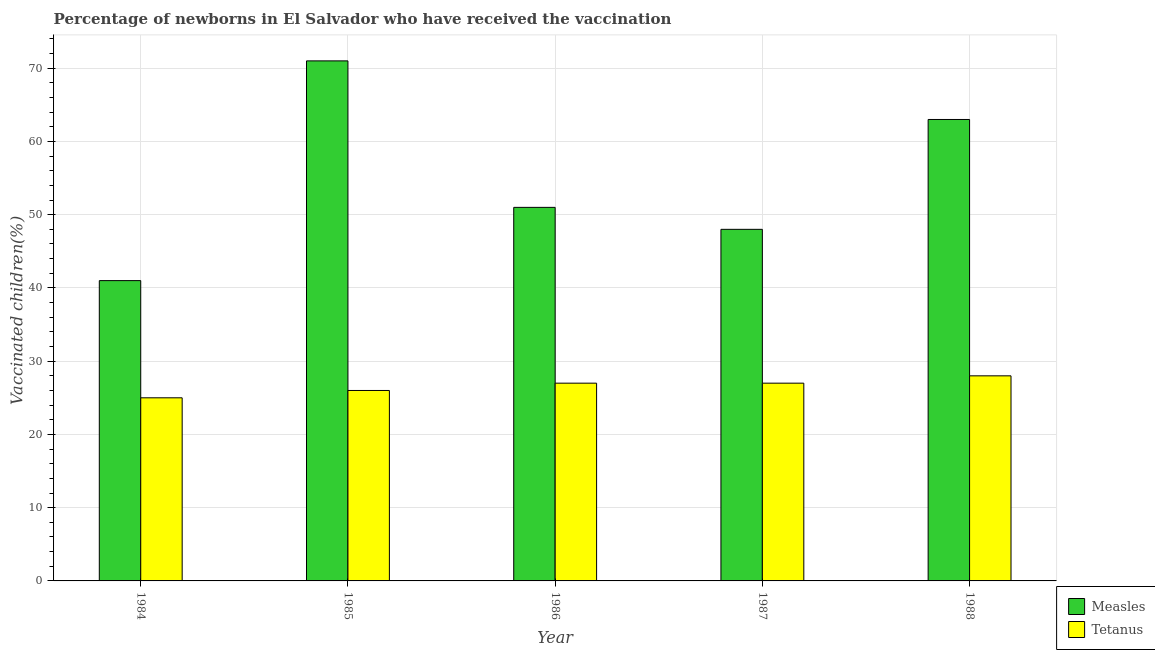How many different coloured bars are there?
Offer a terse response. 2. Are the number of bars per tick equal to the number of legend labels?
Your answer should be compact. Yes. Are the number of bars on each tick of the X-axis equal?
Provide a succinct answer. Yes. How many bars are there on the 3rd tick from the left?
Give a very brief answer. 2. What is the label of the 2nd group of bars from the left?
Ensure brevity in your answer.  1985. What is the percentage of newborns who received vaccination for measles in 1988?
Ensure brevity in your answer.  63. Across all years, what is the maximum percentage of newborns who received vaccination for tetanus?
Offer a very short reply. 28. Across all years, what is the minimum percentage of newborns who received vaccination for measles?
Provide a short and direct response. 41. In which year was the percentage of newborns who received vaccination for measles minimum?
Give a very brief answer. 1984. What is the total percentage of newborns who received vaccination for tetanus in the graph?
Your answer should be compact. 133. What is the difference between the percentage of newborns who received vaccination for measles in 1984 and that in 1988?
Offer a terse response. -22. What is the difference between the percentage of newborns who received vaccination for measles in 1985 and the percentage of newborns who received vaccination for tetanus in 1987?
Make the answer very short. 23. What is the average percentage of newborns who received vaccination for tetanus per year?
Your answer should be very brief. 26.6. In the year 1984, what is the difference between the percentage of newborns who received vaccination for measles and percentage of newborns who received vaccination for tetanus?
Offer a very short reply. 0. What is the ratio of the percentage of newborns who received vaccination for tetanus in 1984 to that in 1988?
Provide a succinct answer. 0.89. Is the difference between the percentage of newborns who received vaccination for tetanus in 1985 and 1988 greater than the difference between the percentage of newborns who received vaccination for measles in 1985 and 1988?
Provide a short and direct response. No. What is the difference between the highest and the second highest percentage of newborns who received vaccination for measles?
Your answer should be very brief. 8. What is the difference between the highest and the lowest percentage of newborns who received vaccination for measles?
Give a very brief answer. 30. What does the 1st bar from the left in 1988 represents?
Provide a short and direct response. Measles. What does the 1st bar from the right in 1984 represents?
Your response must be concise. Tetanus. What is the difference between two consecutive major ticks on the Y-axis?
Give a very brief answer. 10. Does the graph contain grids?
Make the answer very short. Yes. Where does the legend appear in the graph?
Give a very brief answer. Bottom right. What is the title of the graph?
Make the answer very short. Percentage of newborns in El Salvador who have received the vaccination. Does "Lowest 20% of population" appear as one of the legend labels in the graph?
Offer a very short reply. No. What is the label or title of the Y-axis?
Keep it short and to the point. Vaccinated children(%)
. What is the Vaccinated children(%)
 of Tetanus in 1984?
Give a very brief answer. 25. What is the Vaccinated children(%)
 of Measles in 1985?
Provide a short and direct response. 71. What is the Vaccinated children(%)
 in Tetanus in 1985?
Keep it short and to the point. 26. What is the Vaccinated children(%)
 in Tetanus in 1986?
Keep it short and to the point. 27. What is the Vaccinated children(%)
 in Measles in 1988?
Give a very brief answer. 63. Across all years, what is the minimum Vaccinated children(%)
 in Measles?
Give a very brief answer. 41. What is the total Vaccinated children(%)
 of Measles in the graph?
Offer a terse response. 274. What is the total Vaccinated children(%)
 in Tetanus in the graph?
Make the answer very short. 133. What is the difference between the Vaccinated children(%)
 in Measles in 1984 and that in 1986?
Provide a short and direct response. -10. What is the difference between the Vaccinated children(%)
 of Tetanus in 1984 and that in 1987?
Your answer should be compact. -2. What is the difference between the Vaccinated children(%)
 of Tetanus in 1984 and that in 1988?
Give a very brief answer. -3. What is the difference between the Vaccinated children(%)
 of Measles in 1985 and that in 1986?
Your response must be concise. 20. What is the difference between the Vaccinated children(%)
 of Tetanus in 1985 and that in 1987?
Make the answer very short. -1. What is the difference between the Vaccinated children(%)
 in Tetanus in 1985 and that in 1988?
Your response must be concise. -2. What is the difference between the Vaccinated children(%)
 in Measles in 1986 and that in 1987?
Ensure brevity in your answer.  3. What is the difference between the Vaccinated children(%)
 of Measles in 1986 and that in 1988?
Provide a short and direct response. -12. What is the difference between the Vaccinated children(%)
 in Tetanus in 1986 and that in 1988?
Keep it short and to the point. -1. What is the difference between the Vaccinated children(%)
 of Measles in 1987 and that in 1988?
Keep it short and to the point. -15. What is the difference between the Vaccinated children(%)
 of Tetanus in 1987 and that in 1988?
Offer a very short reply. -1. What is the difference between the Vaccinated children(%)
 in Measles in 1984 and the Vaccinated children(%)
 in Tetanus in 1987?
Your response must be concise. 14. What is the difference between the Vaccinated children(%)
 in Measles in 1984 and the Vaccinated children(%)
 in Tetanus in 1988?
Your answer should be very brief. 13. What is the difference between the Vaccinated children(%)
 in Measles in 1985 and the Vaccinated children(%)
 in Tetanus in 1986?
Your answer should be compact. 44. What is the difference between the Vaccinated children(%)
 in Measles in 1985 and the Vaccinated children(%)
 in Tetanus in 1987?
Offer a very short reply. 44. What is the difference between the Vaccinated children(%)
 in Measles in 1985 and the Vaccinated children(%)
 in Tetanus in 1988?
Make the answer very short. 43. What is the difference between the Vaccinated children(%)
 of Measles in 1987 and the Vaccinated children(%)
 of Tetanus in 1988?
Ensure brevity in your answer.  20. What is the average Vaccinated children(%)
 in Measles per year?
Provide a short and direct response. 54.8. What is the average Vaccinated children(%)
 of Tetanus per year?
Your answer should be compact. 26.6. In the year 1988, what is the difference between the Vaccinated children(%)
 of Measles and Vaccinated children(%)
 of Tetanus?
Offer a terse response. 35. What is the ratio of the Vaccinated children(%)
 of Measles in 1984 to that in 1985?
Ensure brevity in your answer.  0.58. What is the ratio of the Vaccinated children(%)
 in Tetanus in 1984 to that in 1985?
Your response must be concise. 0.96. What is the ratio of the Vaccinated children(%)
 in Measles in 1984 to that in 1986?
Ensure brevity in your answer.  0.8. What is the ratio of the Vaccinated children(%)
 in Tetanus in 1984 to that in 1986?
Your response must be concise. 0.93. What is the ratio of the Vaccinated children(%)
 of Measles in 1984 to that in 1987?
Give a very brief answer. 0.85. What is the ratio of the Vaccinated children(%)
 of Tetanus in 1984 to that in 1987?
Ensure brevity in your answer.  0.93. What is the ratio of the Vaccinated children(%)
 of Measles in 1984 to that in 1988?
Provide a short and direct response. 0.65. What is the ratio of the Vaccinated children(%)
 in Tetanus in 1984 to that in 1988?
Give a very brief answer. 0.89. What is the ratio of the Vaccinated children(%)
 in Measles in 1985 to that in 1986?
Give a very brief answer. 1.39. What is the ratio of the Vaccinated children(%)
 of Tetanus in 1985 to that in 1986?
Ensure brevity in your answer.  0.96. What is the ratio of the Vaccinated children(%)
 of Measles in 1985 to that in 1987?
Provide a short and direct response. 1.48. What is the ratio of the Vaccinated children(%)
 in Measles in 1985 to that in 1988?
Offer a terse response. 1.13. What is the ratio of the Vaccinated children(%)
 of Tetanus in 1985 to that in 1988?
Offer a terse response. 0.93. What is the ratio of the Vaccinated children(%)
 of Tetanus in 1986 to that in 1987?
Provide a succinct answer. 1. What is the ratio of the Vaccinated children(%)
 of Measles in 1986 to that in 1988?
Offer a terse response. 0.81. What is the ratio of the Vaccinated children(%)
 of Tetanus in 1986 to that in 1988?
Keep it short and to the point. 0.96. What is the ratio of the Vaccinated children(%)
 of Measles in 1987 to that in 1988?
Give a very brief answer. 0.76. What is the difference between the highest and the second highest Vaccinated children(%)
 of Measles?
Your answer should be compact. 8. 